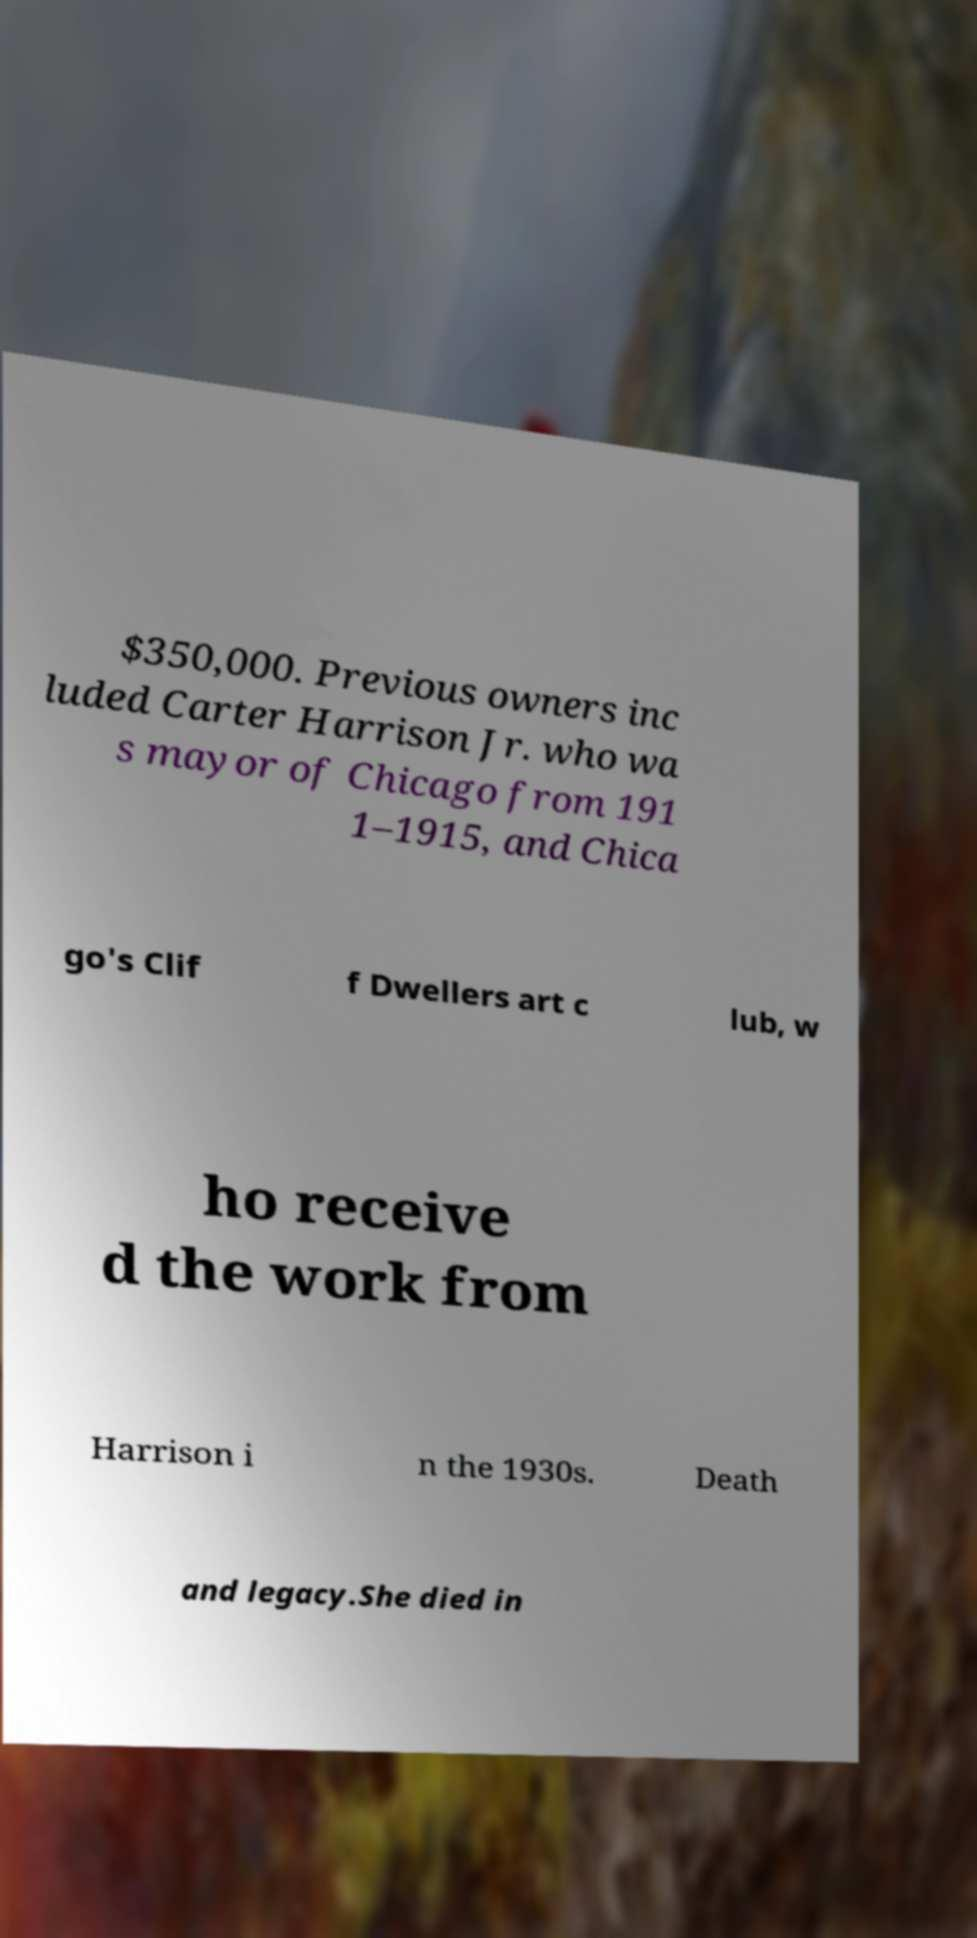Can you accurately transcribe the text from the provided image for me? $350,000. Previous owners inc luded Carter Harrison Jr. who wa s mayor of Chicago from 191 1–1915, and Chica go's Clif f Dwellers art c lub, w ho receive d the work from Harrison i n the 1930s. Death and legacy.She died in 